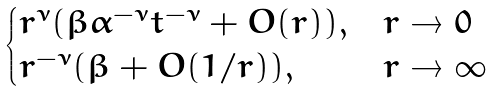<formula> <loc_0><loc_0><loc_500><loc_500>\begin{cases} r ^ { \nu } ( \beta \alpha ^ { - \nu } t ^ { - \nu } + O ( r ) ) , & r \rightarrow 0 \\ r ^ { - \nu } ( \beta + O ( 1 / r ) ) , & r \rightarrow \infty \\ \end{cases}</formula> 